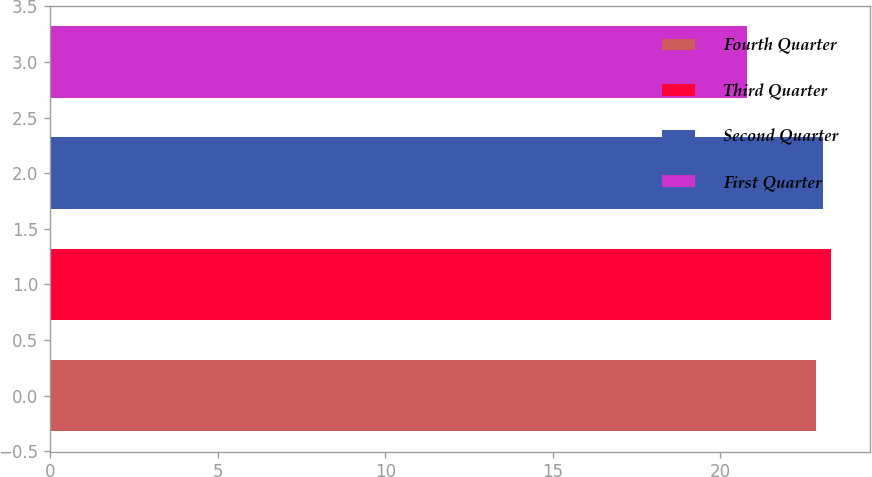Convert chart. <chart><loc_0><loc_0><loc_500><loc_500><bar_chart><fcel>Fourth Quarter<fcel>Third Quarter<fcel>Second Quarter<fcel>First Quarter<nl><fcel>22.84<fcel>23.3<fcel>23.07<fcel>20.78<nl></chart> 